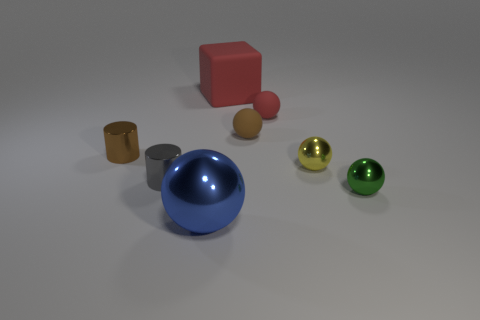Can you describe the textures of the objects visible? Certainly, the objects in the image exhibit various textures. The spheres have a glossy finish, reflecting light and showcasing their smooth surfaces. The cube and the cylindrical objects appear to have a matte finish, which absorbs light and suggests a non-reflective, possibly rough texture. 